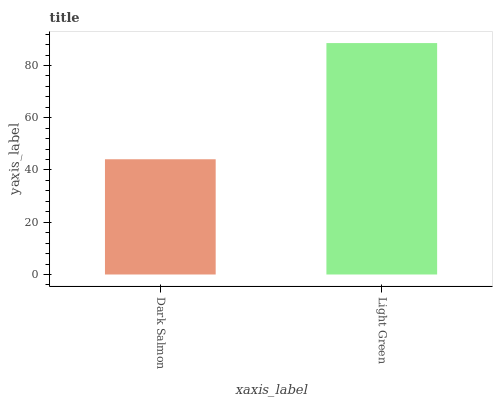Is Dark Salmon the minimum?
Answer yes or no. Yes. Is Light Green the maximum?
Answer yes or no. Yes. Is Light Green the minimum?
Answer yes or no. No. Is Light Green greater than Dark Salmon?
Answer yes or no. Yes. Is Dark Salmon less than Light Green?
Answer yes or no. Yes. Is Dark Salmon greater than Light Green?
Answer yes or no. No. Is Light Green less than Dark Salmon?
Answer yes or no. No. Is Light Green the high median?
Answer yes or no. Yes. Is Dark Salmon the low median?
Answer yes or no. Yes. Is Dark Salmon the high median?
Answer yes or no. No. Is Light Green the low median?
Answer yes or no. No. 